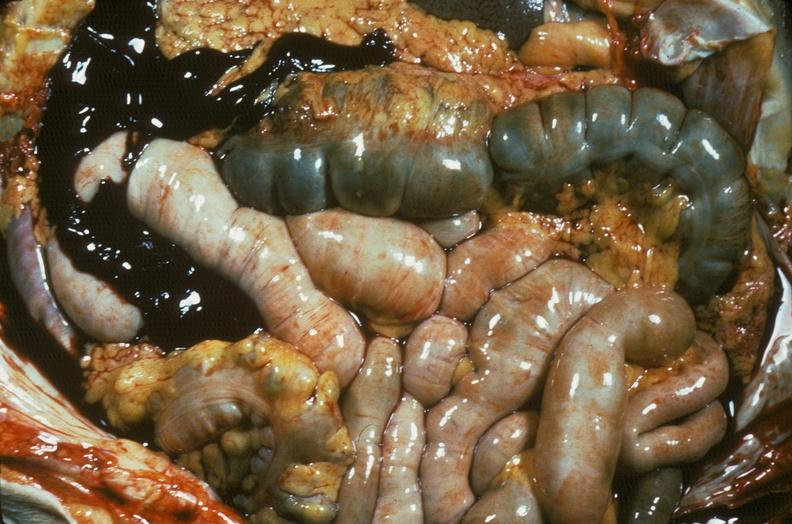does abdomen show hemorrhage secondary to ruptured aneurysm?
Answer the question using a single word or phrase. No 